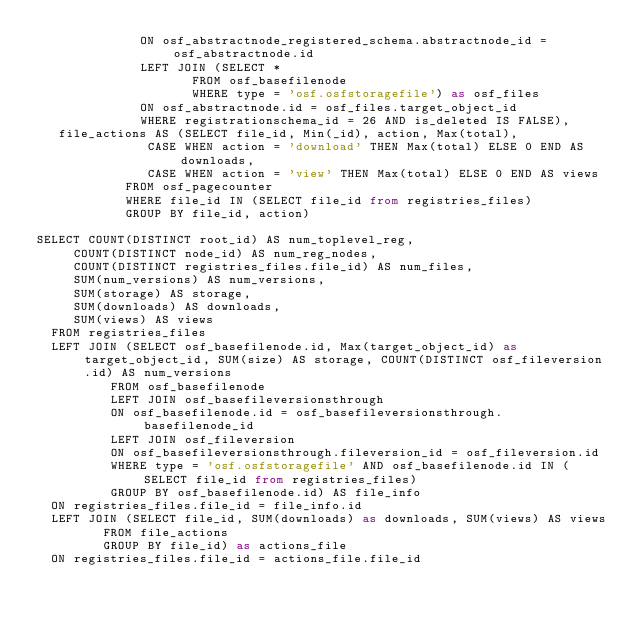Convert code to text. <code><loc_0><loc_0><loc_500><loc_500><_SQL_>							ON osf_abstractnode_registered_schema.abstractnode_id = osf_abstractnode.id
							LEFT JOIN (SELECT *
										 FROM osf_basefilenode
										 WHERE type = 'osf.osfstoragefile') as osf_files
							ON osf_abstractnode.id = osf_files.target_object_id
							WHERE registrationschema_id = 26 AND is_deleted IS FALSE),
	 file_actions AS (SELECT file_id, Min(_id), action, Max(total),
	 						 CASE WHEN action = 'download' THEN Max(total) ELSE 0 END AS downloads,
							 CASE WHEN action = 'view' THEN Max(total) ELSE 0 END AS views
						FROM osf_pagecounter
						WHERE file_id IN (SELECT file_id from registries_files)
						GROUP BY file_id, action)

SELECT COUNT(DISTINCT root_id) AS num_toplevel_reg,
	   COUNT(DISTINCT node_id) AS num_reg_nodes,
	   COUNT(DISTINCT registries_files.file_id) AS num_files,
	   SUM(num_versions) AS num_versions,
	   SUM(storage) AS storage,
	   SUM(downloads) AS downloads,
	   SUM(views) AS views
	FROM registries_files
	LEFT JOIN (SELECT osf_basefilenode.id, Max(target_object_id) as target_object_id, SUM(size) AS storage, COUNT(DISTINCT osf_fileversion.id) AS num_versions
					FROM osf_basefilenode
					LEFT JOIN osf_basefileversionsthrough
					ON osf_basefilenode.id = osf_basefileversionsthrough.basefilenode_id
					LEFT JOIN osf_fileversion
					ON osf_basefileversionsthrough.fileversion_id = osf_fileversion.id
					WHERE type = 'osf.osfstoragefile' AND osf_basefilenode.id IN (SELECT file_id from registries_files)
					GROUP BY osf_basefilenode.id) AS file_info
	ON registries_files.file_id = file_info.id
	LEFT JOIN (SELECT file_id, SUM(downloads) as downloads, SUM(views) AS views
				 FROM file_actions
				 GROUP BY file_id) as actions_file
	ON registries_files.file_id = actions_file.file_id</code> 